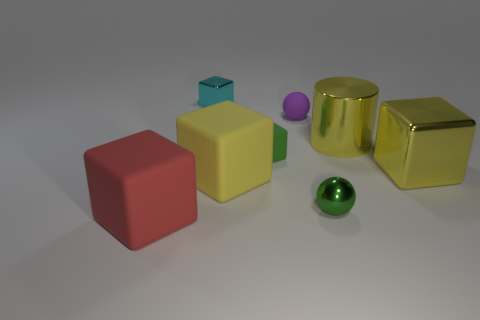Subtract all yellow blocks. How many blocks are left? 3 Subtract all cyan cubes. How many cubes are left? 4 Add 1 green matte blocks. How many green matte blocks exist? 2 Add 2 yellow rubber blocks. How many objects exist? 10 Subtract 1 green spheres. How many objects are left? 7 Subtract all cylinders. How many objects are left? 7 Subtract 4 blocks. How many blocks are left? 1 Subtract all blue cylinders. Subtract all cyan spheres. How many cylinders are left? 1 Subtract all red balls. How many green cubes are left? 1 Subtract all tiny cyan metal things. Subtract all large rubber spheres. How many objects are left? 7 